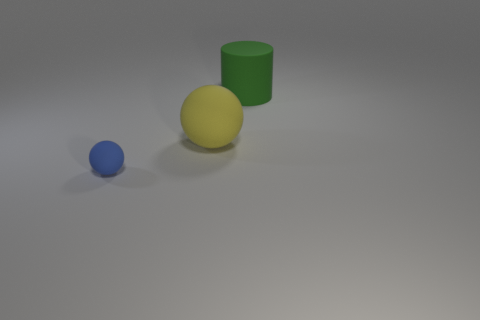Are there any other things that have the same size as the blue matte thing?
Ensure brevity in your answer.  No. How many big objects are either brown rubber objects or yellow balls?
Your response must be concise. 1. Is the number of red objects less than the number of big spheres?
Provide a succinct answer. Yes. There is a rubber sphere left of the big sphere; is it the same size as the ball behind the small blue rubber ball?
Keep it short and to the point. No. What number of brown things are large matte things or rubber things?
Give a very brief answer. 0. Are there more large cylinders than tiny green rubber objects?
Ensure brevity in your answer.  Yes. Is the color of the tiny object the same as the big matte ball?
Ensure brevity in your answer.  No. What number of objects are either tiny rubber cylinders or things that are in front of the matte cylinder?
Offer a terse response. 2. How many other objects are the same shape as the small blue thing?
Your response must be concise. 1. Is the number of large green matte things that are behind the matte cylinder less than the number of small matte objects that are to the right of the yellow rubber object?
Provide a succinct answer. No. 